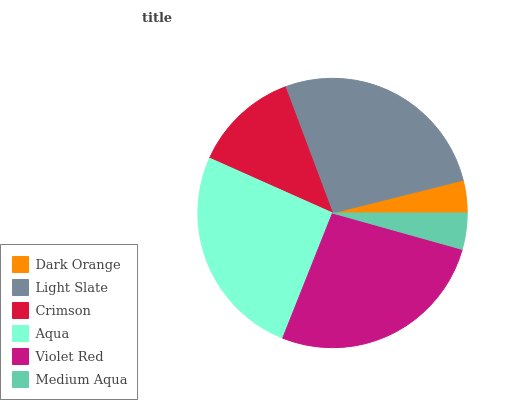Is Dark Orange the minimum?
Answer yes or no. Yes. Is Light Slate the maximum?
Answer yes or no. Yes. Is Crimson the minimum?
Answer yes or no. No. Is Crimson the maximum?
Answer yes or no. No. Is Light Slate greater than Crimson?
Answer yes or no. Yes. Is Crimson less than Light Slate?
Answer yes or no. Yes. Is Crimson greater than Light Slate?
Answer yes or no. No. Is Light Slate less than Crimson?
Answer yes or no. No. Is Aqua the high median?
Answer yes or no. Yes. Is Crimson the low median?
Answer yes or no. Yes. Is Violet Red the high median?
Answer yes or no. No. Is Dark Orange the low median?
Answer yes or no. No. 